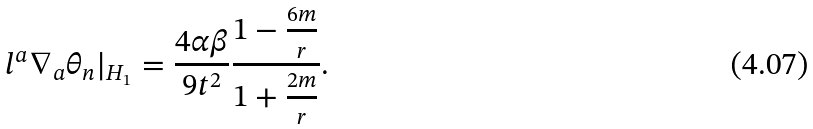Convert formula to latex. <formula><loc_0><loc_0><loc_500><loc_500>l ^ { a } \nabla _ { a } \theta _ { n } | _ { H _ { 1 } } = \frac { 4 \alpha \beta } { 9 t ^ { 2 } } \frac { 1 - \frac { 6 m } { r } } { 1 + \frac { 2 m } { r } } .</formula> 